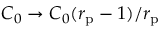Convert formula to latex. <formula><loc_0><loc_0><loc_500><loc_500>C _ { 0 } \to C _ { 0 } ( r _ { p } - 1 ) / r _ { p }</formula> 